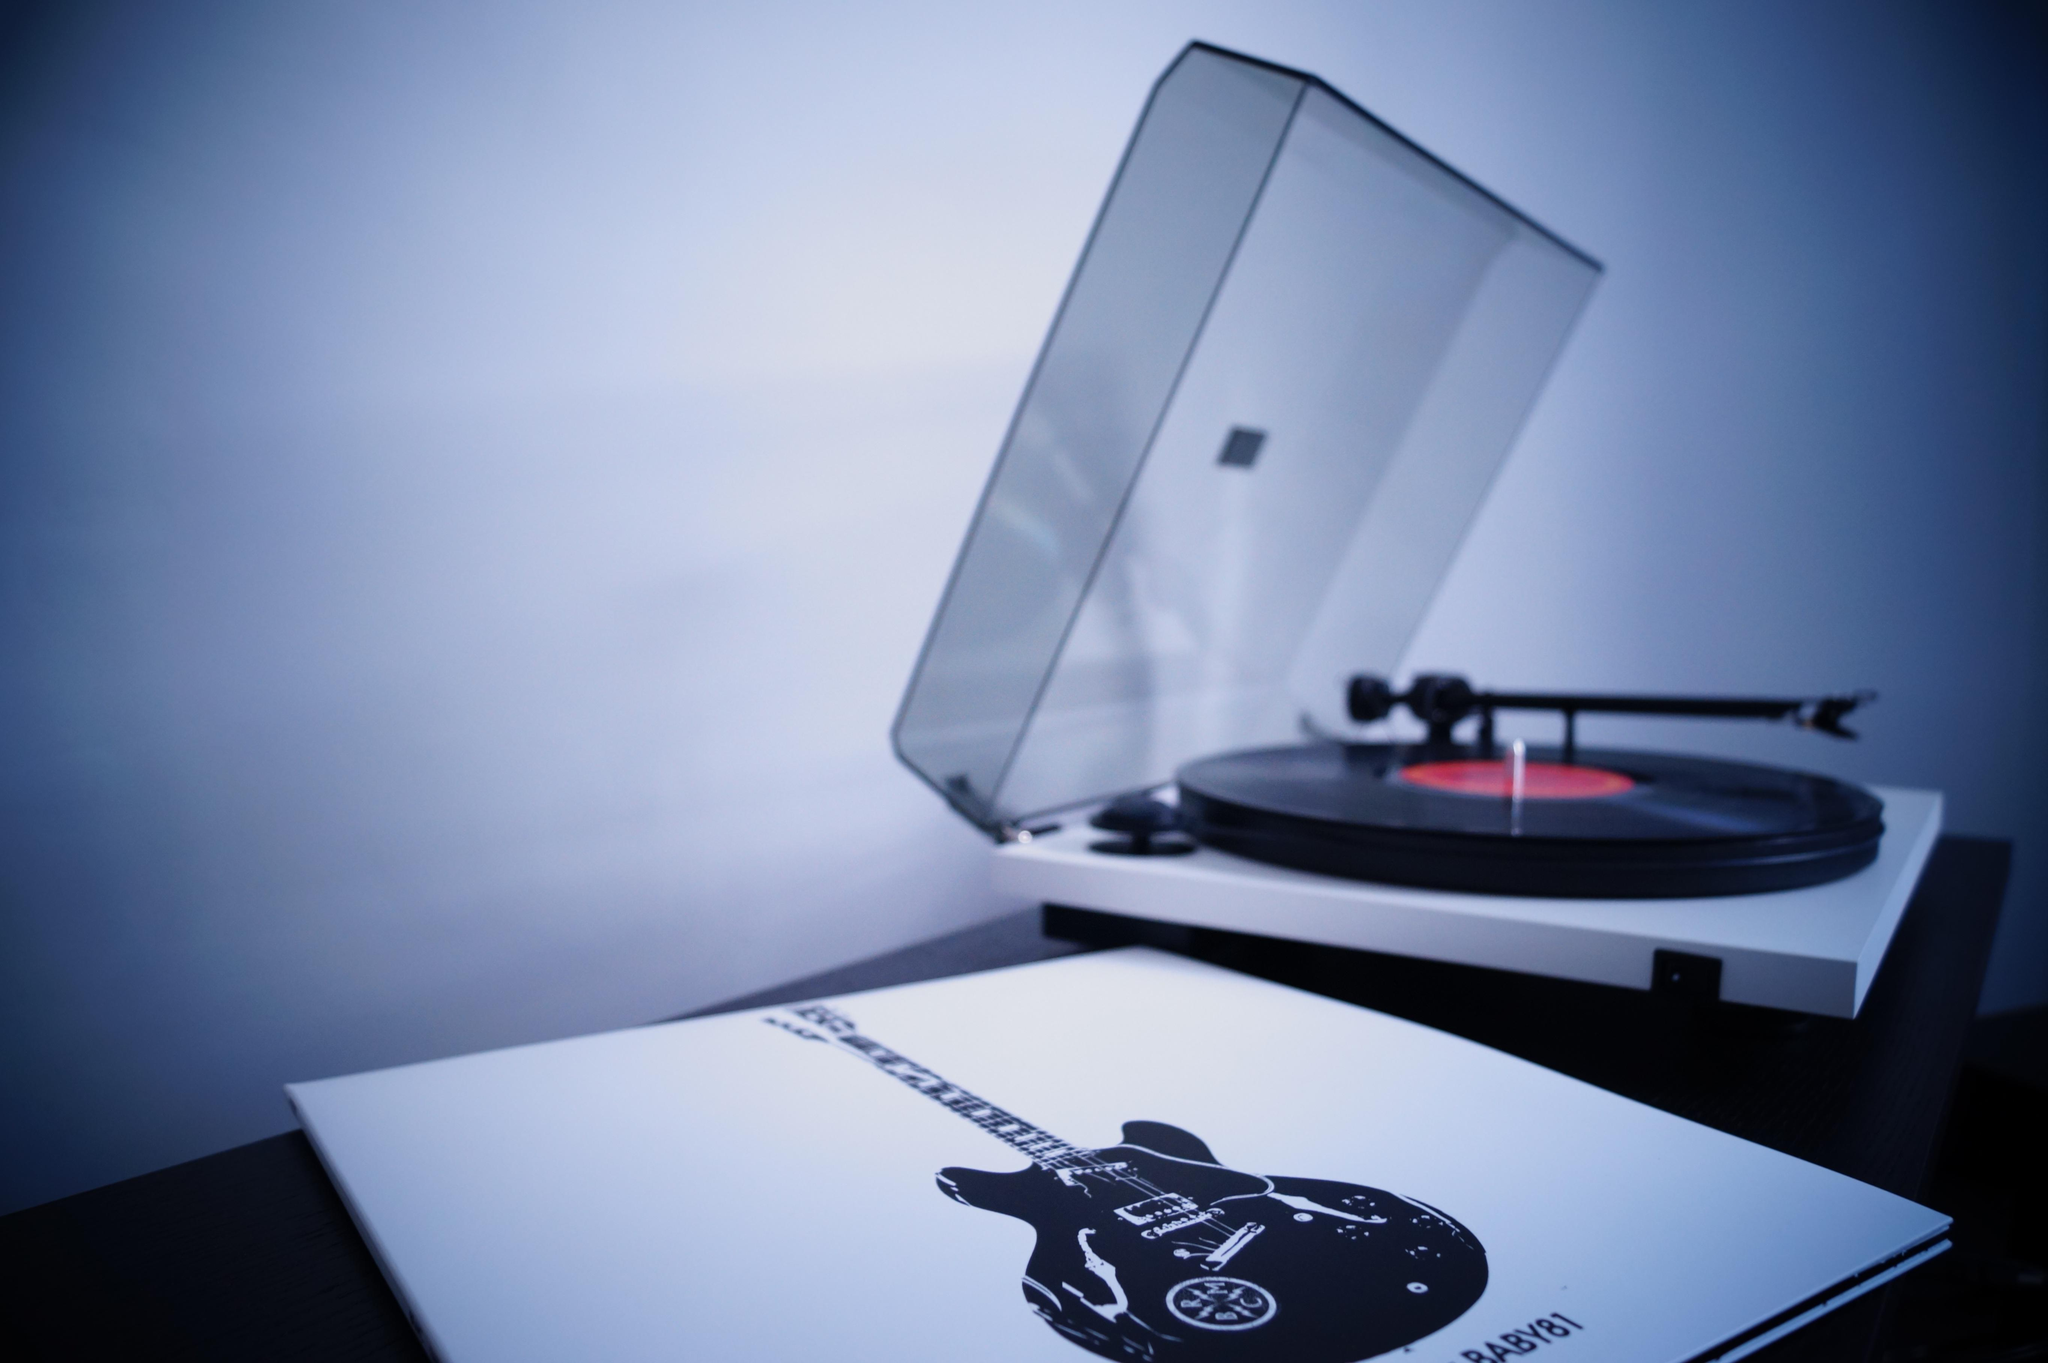What type of music device is present in the image? There is a gramophone record player in the image. What object can be seen on the table in the image? There is a book on the table in the image. What can be seen in the background of the image? There is a wall in the background of the image. What is the surprise that the book on the table is holding in the image? There is no indication of a surprise in the image; the book is simply present on the table. What is your opinion on the design of the wall in the background? The provided facts do not include any information about the design of the wall, so it is not possible to provide an opinion on it. 